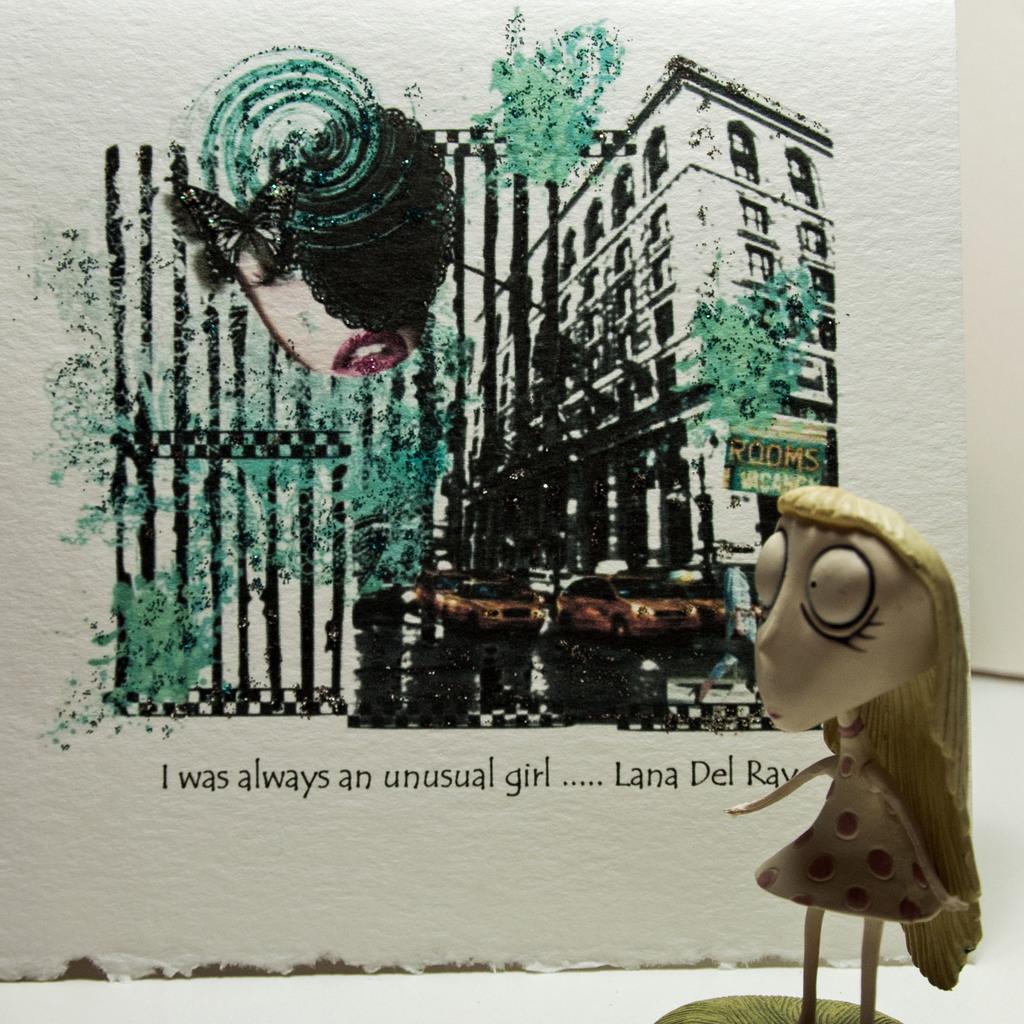How would you summarize this image in a sentence or two? In this picture we can see a toy in the front, in the background there is a board, we can see picture of a building, cars and some text on the board. 